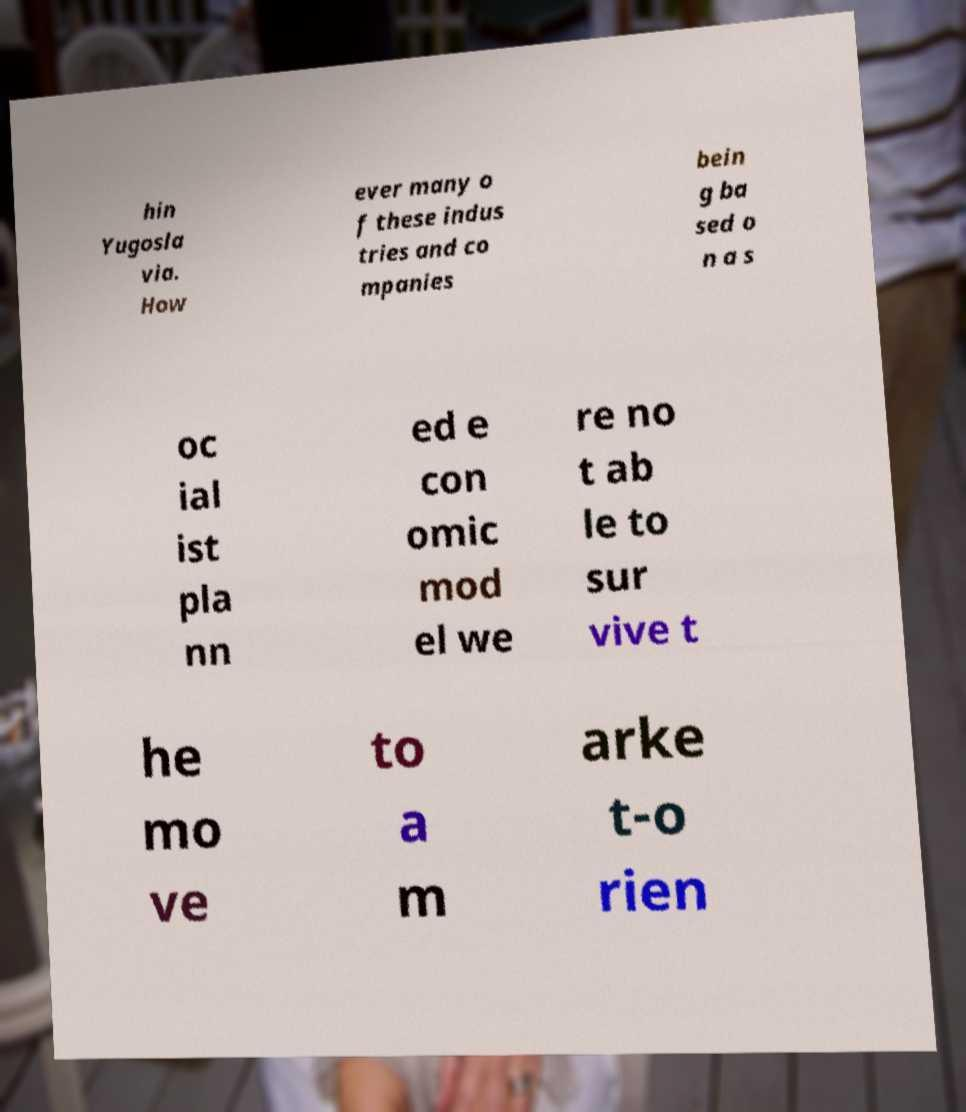There's text embedded in this image that I need extracted. Can you transcribe it verbatim? hin Yugosla via. How ever many o f these indus tries and co mpanies bein g ba sed o n a s oc ial ist pla nn ed e con omic mod el we re no t ab le to sur vive t he mo ve to a m arke t-o rien 